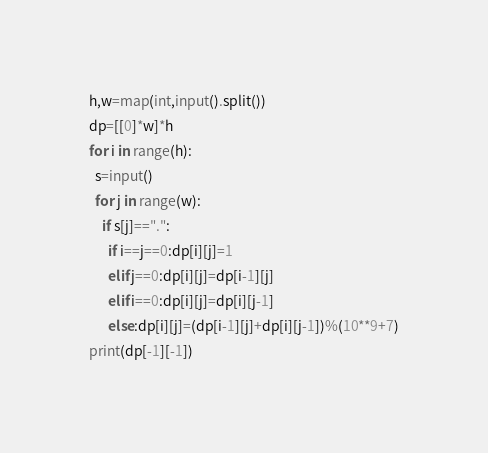<code> <loc_0><loc_0><loc_500><loc_500><_Python_>h,w=map(int,input().split())
dp=[[0]*w]*h
for i in range(h):
  s=input()
  for j in range(w):
    if s[j]==".":
      if i==j==0:dp[i][j]=1
      elif j==0:dp[i][j]=dp[i-1][j]
      elif i==0:dp[i][j]=dp[i][j-1]
      else:dp[i][j]=(dp[i-1][j]+dp[i][j-1])%(10**9+7)
print(dp[-1][-1])</code> 